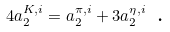<formula> <loc_0><loc_0><loc_500><loc_500>4 a _ { 2 } ^ { K , i } = a _ { 2 } ^ { \pi , i } + 3 a _ { 2 } ^ { \eta , i } \text { .}</formula> 